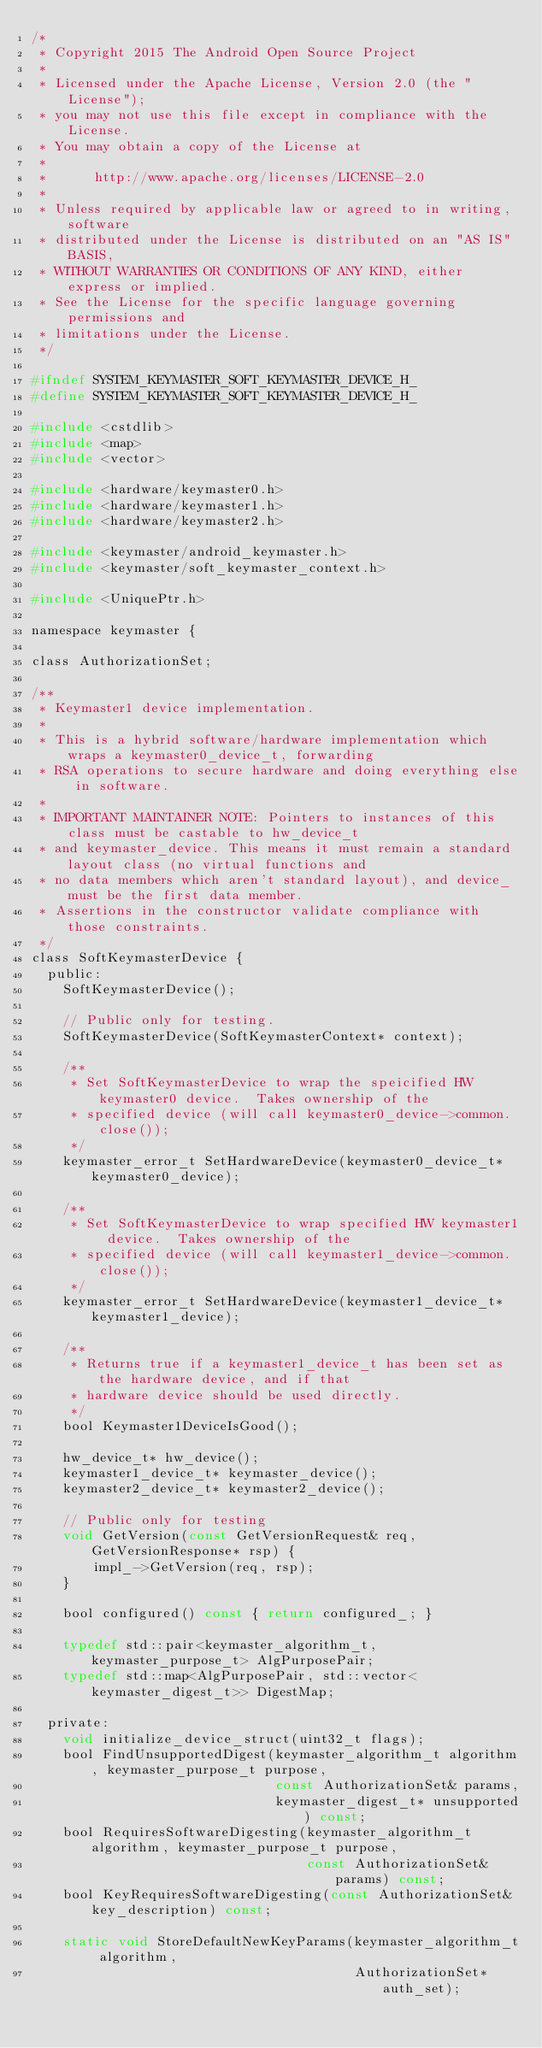Convert code to text. <code><loc_0><loc_0><loc_500><loc_500><_C_>/*
 * Copyright 2015 The Android Open Source Project
 *
 * Licensed under the Apache License, Version 2.0 (the "License");
 * you may not use this file except in compliance with the License.
 * You may obtain a copy of the License at
 *
 *      http://www.apache.org/licenses/LICENSE-2.0
 *
 * Unless required by applicable law or agreed to in writing, software
 * distributed under the License is distributed on an "AS IS" BASIS,
 * WITHOUT WARRANTIES OR CONDITIONS OF ANY KIND, either express or implied.
 * See the License for the specific language governing permissions and
 * limitations under the License.
 */

#ifndef SYSTEM_KEYMASTER_SOFT_KEYMASTER_DEVICE_H_
#define SYSTEM_KEYMASTER_SOFT_KEYMASTER_DEVICE_H_

#include <cstdlib>
#include <map>
#include <vector>

#include <hardware/keymaster0.h>
#include <hardware/keymaster1.h>
#include <hardware/keymaster2.h>

#include <keymaster/android_keymaster.h>
#include <keymaster/soft_keymaster_context.h>

#include <UniquePtr.h>

namespace keymaster {

class AuthorizationSet;

/**
 * Keymaster1 device implementation.
 *
 * This is a hybrid software/hardware implementation which wraps a keymaster0_device_t, forwarding
 * RSA operations to secure hardware and doing everything else in software.
 *
 * IMPORTANT MAINTAINER NOTE: Pointers to instances of this class must be castable to hw_device_t
 * and keymaster_device. This means it must remain a standard layout class (no virtual functions and
 * no data members which aren't standard layout), and device_ must be the first data member.
 * Assertions in the constructor validate compliance with those constraints.
 */
class SoftKeymasterDevice {
  public:
    SoftKeymasterDevice();

    // Public only for testing.
    SoftKeymasterDevice(SoftKeymasterContext* context);

    /**
     * Set SoftKeymasterDevice to wrap the speicified HW keymaster0 device.  Takes ownership of the
     * specified device (will call keymaster0_device->common.close());
     */
    keymaster_error_t SetHardwareDevice(keymaster0_device_t* keymaster0_device);

    /**
     * Set SoftKeymasterDevice to wrap specified HW keymaster1 device.  Takes ownership of the
     * specified device (will call keymaster1_device->common.close());
     */
    keymaster_error_t SetHardwareDevice(keymaster1_device_t* keymaster1_device);

    /**
     * Returns true if a keymaster1_device_t has been set as the hardware device, and if that
     * hardware device should be used directly.
     */
    bool Keymaster1DeviceIsGood();

    hw_device_t* hw_device();
    keymaster1_device_t* keymaster_device();
    keymaster2_device_t* keymaster2_device();

    // Public only for testing
    void GetVersion(const GetVersionRequest& req, GetVersionResponse* rsp) {
        impl_->GetVersion(req, rsp);
    }

    bool configured() const { return configured_; }

    typedef std::pair<keymaster_algorithm_t, keymaster_purpose_t> AlgPurposePair;
    typedef std::map<AlgPurposePair, std::vector<keymaster_digest_t>> DigestMap;

  private:
    void initialize_device_struct(uint32_t flags);
    bool FindUnsupportedDigest(keymaster_algorithm_t algorithm, keymaster_purpose_t purpose,
                               const AuthorizationSet& params,
                               keymaster_digest_t* unsupported) const;
    bool RequiresSoftwareDigesting(keymaster_algorithm_t algorithm, keymaster_purpose_t purpose,
                                   const AuthorizationSet& params) const;
    bool KeyRequiresSoftwareDigesting(const AuthorizationSet& key_description) const;

    static void StoreDefaultNewKeyParams(keymaster_algorithm_t algorithm,
                                         AuthorizationSet* auth_set);</code> 